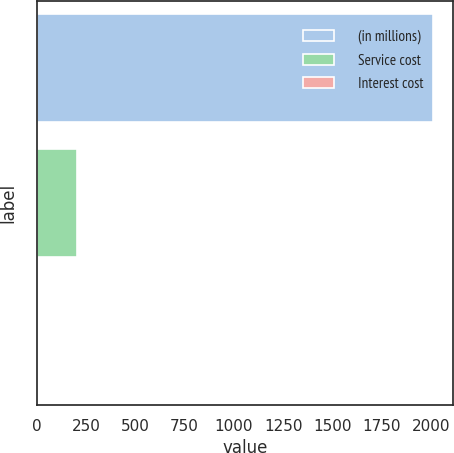Convert chart. <chart><loc_0><loc_0><loc_500><loc_500><bar_chart><fcel>(in millions)<fcel>Service cost<fcel>Interest cost<nl><fcel>2010<fcel>204.6<fcel>4<nl></chart> 